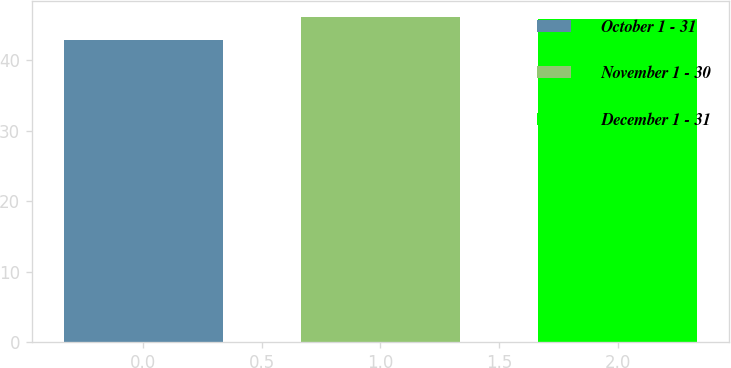Convert chart. <chart><loc_0><loc_0><loc_500><loc_500><bar_chart><fcel>October 1 - 31<fcel>November 1 - 30<fcel>December 1 - 31<nl><fcel>42.92<fcel>46.14<fcel>45.83<nl></chart> 